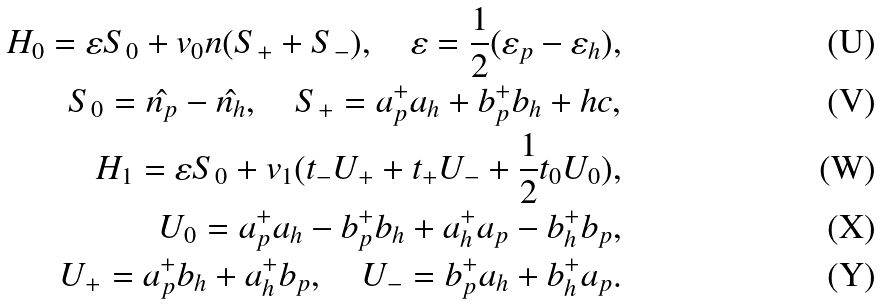Convert formula to latex. <formula><loc_0><loc_0><loc_500><loc_500>H _ { 0 } = \varepsilon S _ { 0 } + v _ { 0 } n ( S _ { + } + S _ { - } ) , \quad \varepsilon = \frac { 1 } { 2 } ( \varepsilon _ { p } - \varepsilon _ { h } ) , \\ S _ { 0 } = \hat { n _ { p } } - \hat { n _ { h } } , \quad S _ { + } = a _ { p } ^ { + } a _ { h } + b _ { p } ^ { + } b _ { h } + h c , \\ H _ { 1 } = \varepsilon S _ { 0 } + v _ { 1 } ( t _ { - } U _ { + } + t _ { + } U _ { - } + \frac { 1 } { 2 } t _ { 0 } U _ { 0 } ) , \\ U _ { 0 } = a _ { p } ^ { + } a _ { h } - b _ { p } ^ { + } b _ { h } + a _ { h } ^ { + } a _ { p } - b _ { h } ^ { + } b _ { p } , \\ U _ { + } = a _ { p } ^ { + } b _ { h } + a ^ { + } _ { h } b _ { p } , \quad U _ { - } = b ^ { + } _ { p } a _ { h } + b ^ { + } _ { h } a _ { p } .</formula> 